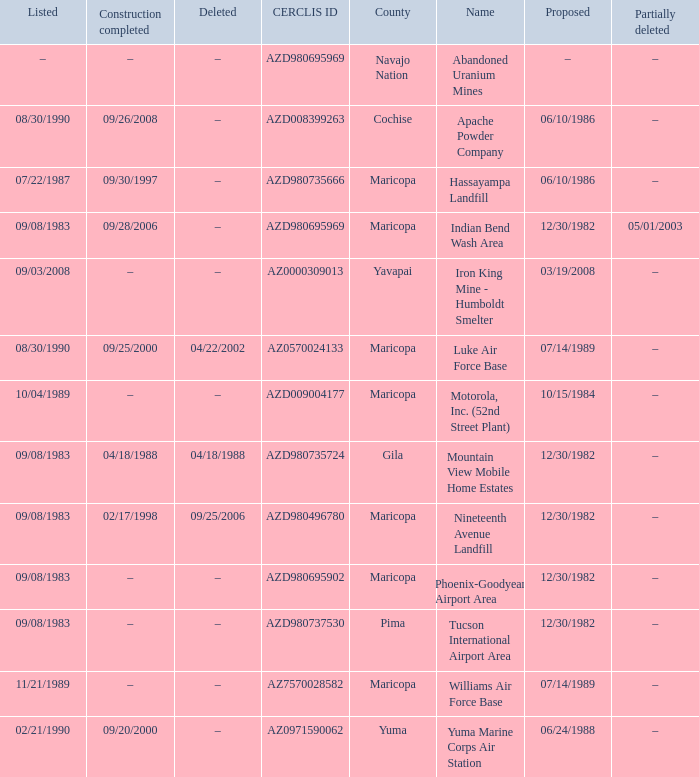When was the site partially deleted when the cerclis id is az7570028582? –. 